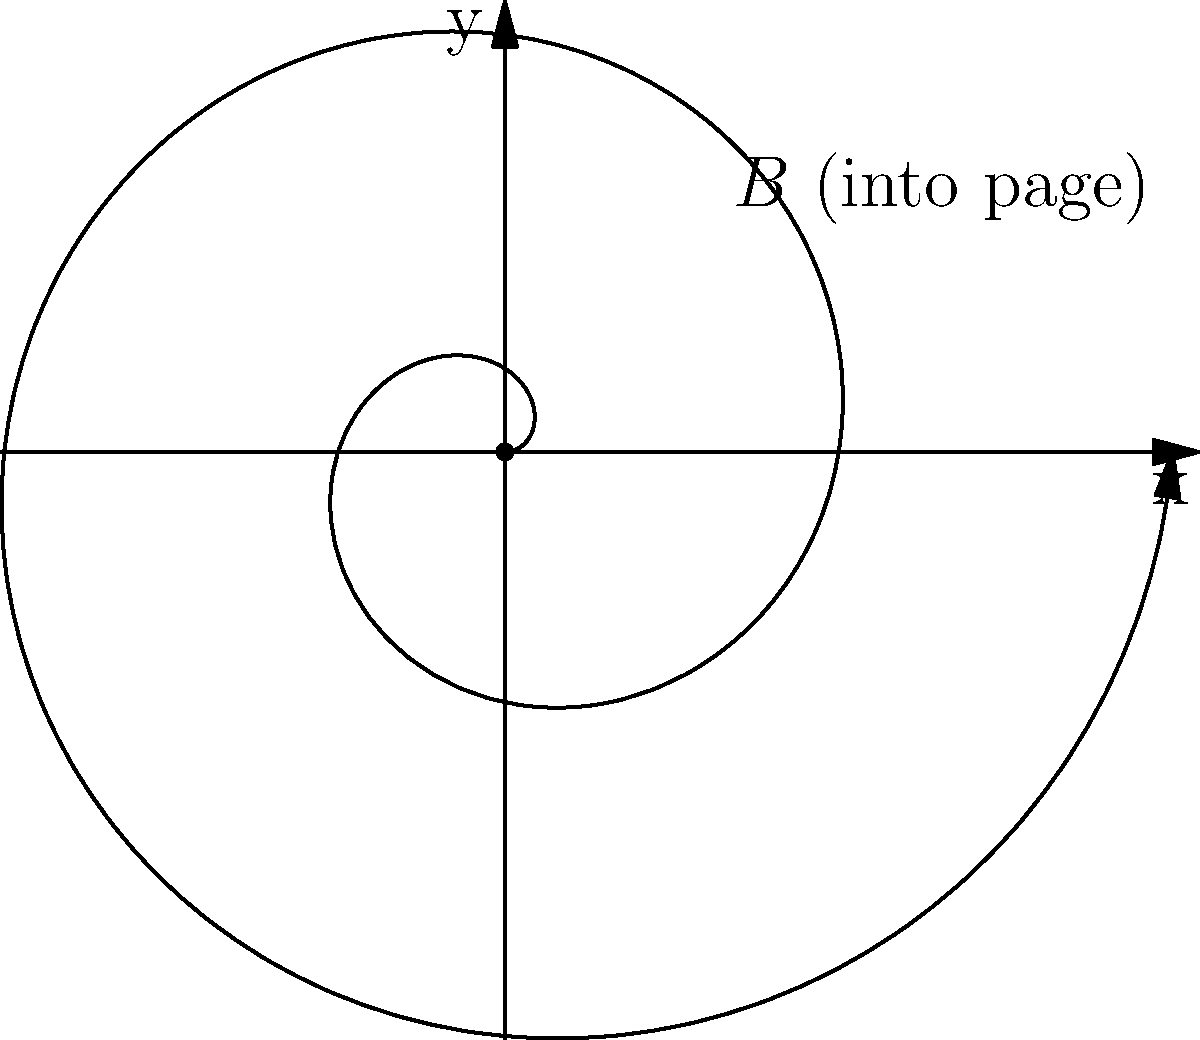In a uniform magnetic field $B$ directed into the page, a positively charged particle is released from the origin with an initial velocity perpendicular to the field. The particle's path forms a spiral as shown in the figure. If the radius of the spiral doubles after one complete revolution, what is the angle $\theta$ (in radians) between the particle's initial velocity vector and its velocity vector after completing exactly two revolutions? Let's approach this step-by-step:

1) In a uniform magnetic field, a charged particle moves in a circular path when its velocity is perpendicular to the field. The spiral path we see is due to an additional velocity component parallel to the field.

2) The radius of the spiral is proportional to the distance from the origin. After one revolution (2π radians), the radius doubles. This means that for every 2π increase in the angle, the radius doubles.

3) We can express this mathematically: $r(\theta) = r_0 \cdot 2^{\frac{\theta}{2\pi}}$, where $r_0$ is the initial radius.

4) After two complete revolutions, $\theta = 4\pi$ radians. Let's call the final radius $r_f$:

   $r_f = r_0 \cdot 2^{\frac{4\pi}{2\pi}} = r_0 \cdot 2^2 = 4r_0$

5) The particle's velocity can be decomposed into a tangential component (perpendicular to the radius) and a radial component (parallel to the radius).

6) The angle between the initial velocity (purely tangential) and the final velocity is the same as the angle between the radius and the tangent to the spiral at the final point.

7) This angle can be found using the formula: $\tan \phi = \frac{r}{dr/d\theta}$

8) We can calculate $\frac{dr}{d\theta}$:
   
   $\frac{dr}{d\theta} = r_0 \cdot 2^{\frac{\theta}{2\pi}} \cdot \frac{\ln 2}{2\pi} = \frac{r(\theta) \ln 2}{2\pi}$

9) At $\theta = 4\pi$, $r = 4r_0$, so:

   $\tan \phi = \frac{4r_0}{\frac{4r_0 \ln 2}{2\pi}} = \frac{2\pi}{\ln 2} \approx 9.06$

10) Therefore, $\phi = \arctan(\frac{2\pi}{\ln 2}) \approx 1.50$ radians
Answer: $\arctan(\frac{2\pi}{\ln 2})$ radians 